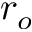<formula> <loc_0><loc_0><loc_500><loc_500>r _ { o }</formula> 